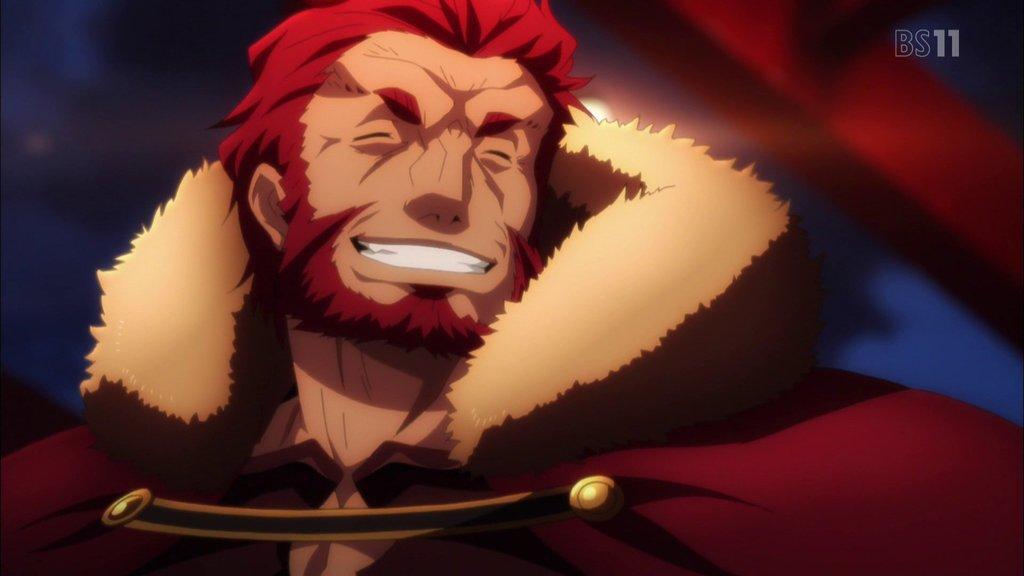Can you describe this image briefly? This is an animated image. On the top right, there is a watermark. And the background is blurred. 